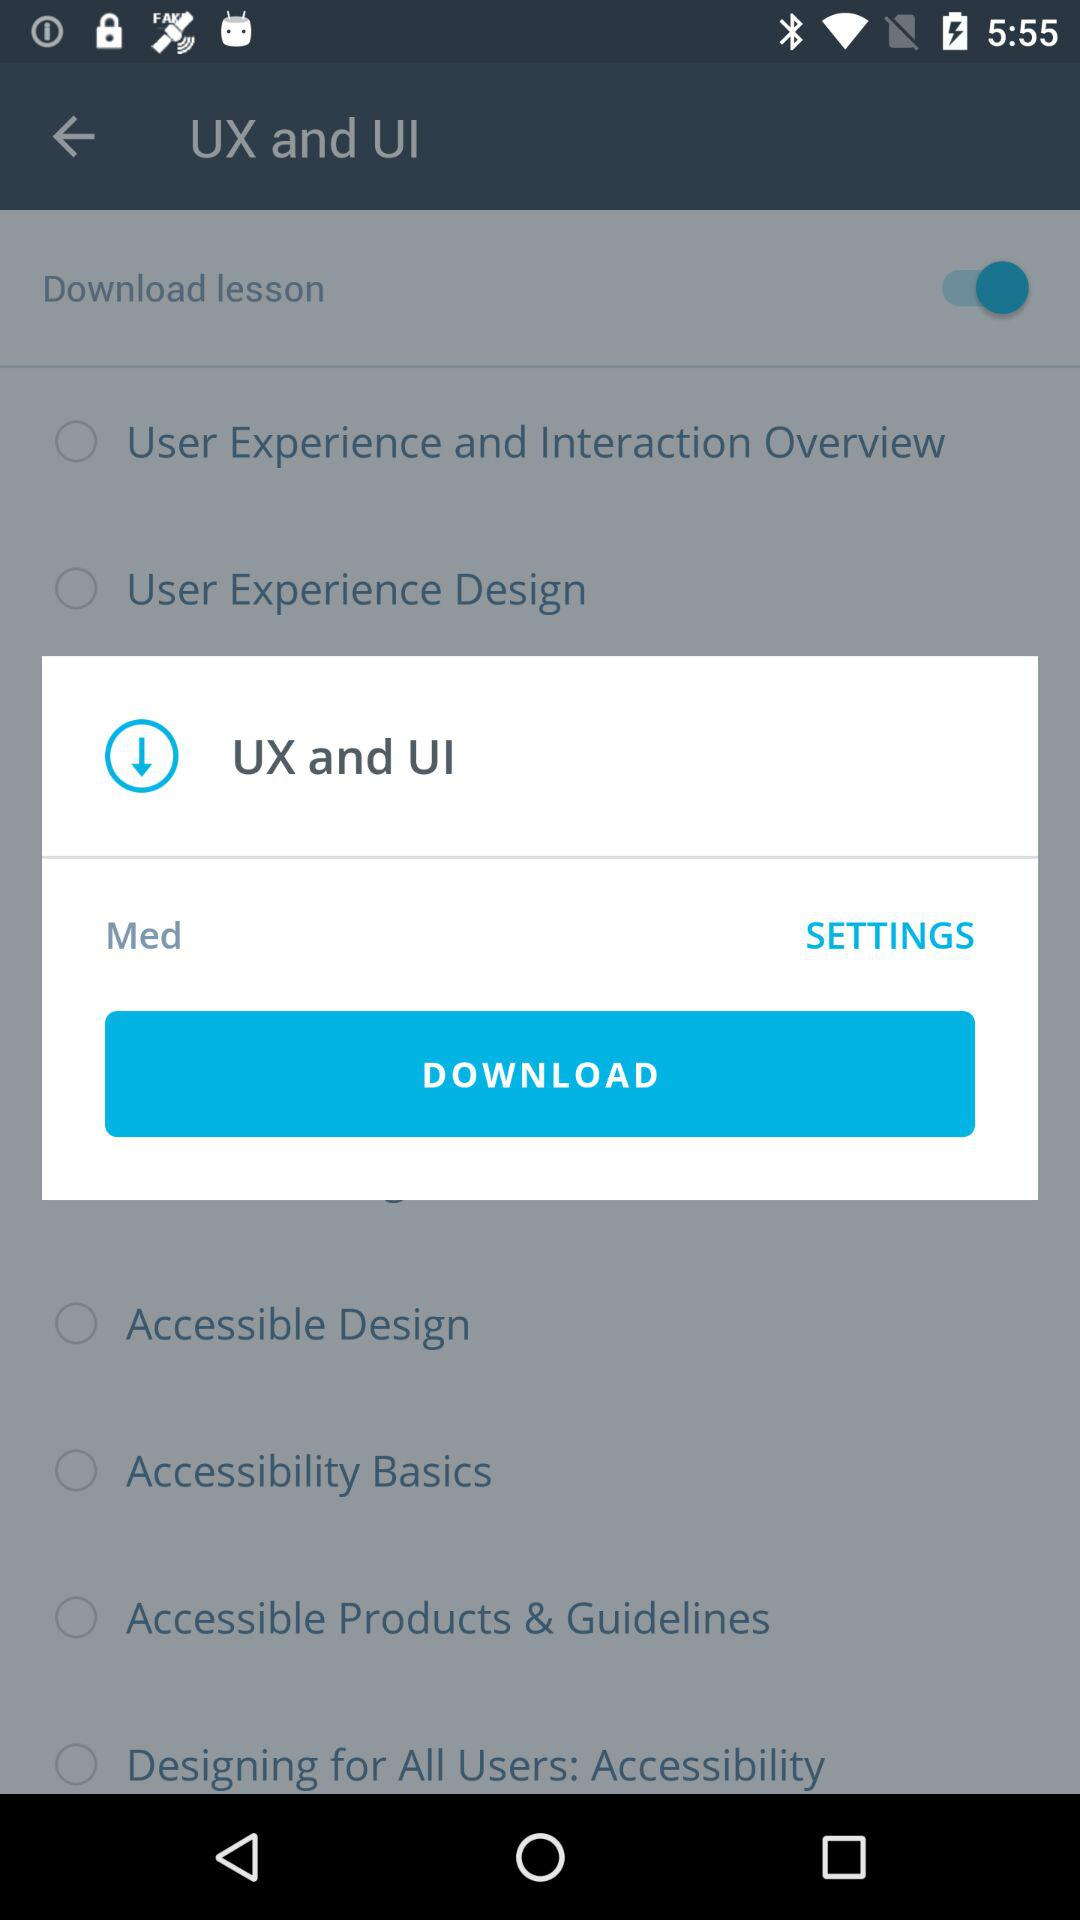What is the name of application?
When the provided information is insufficient, respond with <no answer>. <no answer> 